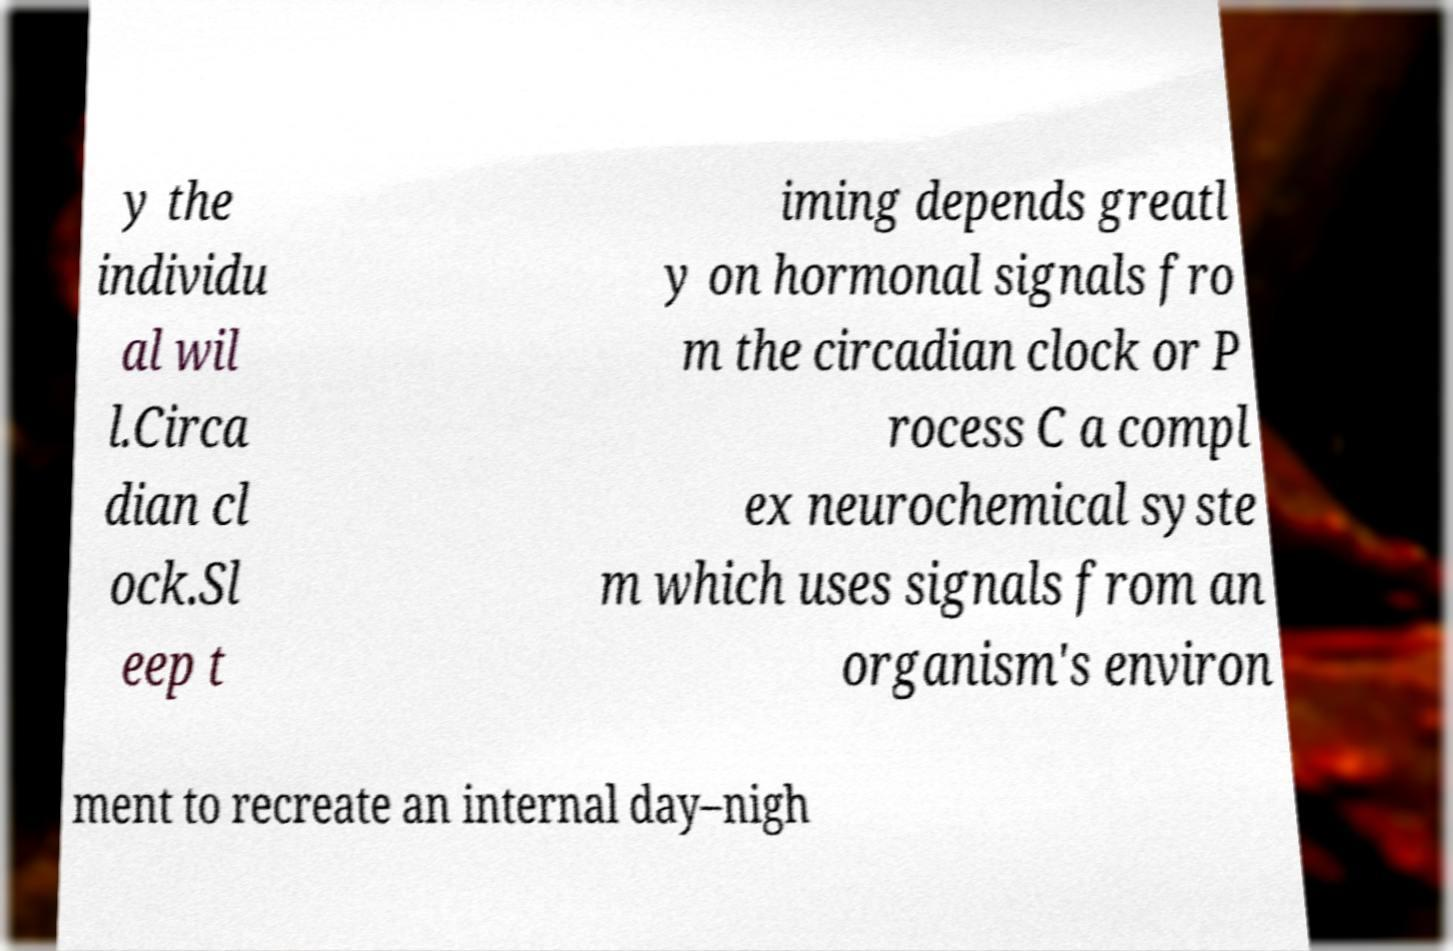Can you read and provide the text displayed in the image?This photo seems to have some interesting text. Can you extract and type it out for me? y the individu al wil l.Circa dian cl ock.Sl eep t iming depends greatl y on hormonal signals fro m the circadian clock or P rocess C a compl ex neurochemical syste m which uses signals from an organism's environ ment to recreate an internal day–nigh 